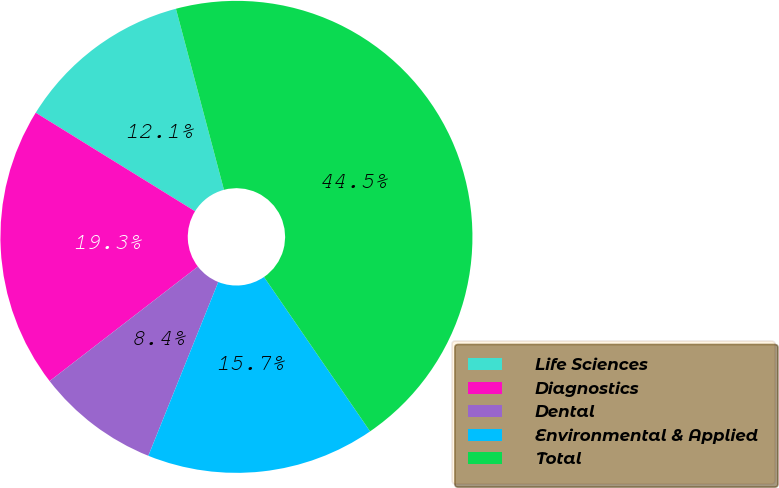<chart> <loc_0><loc_0><loc_500><loc_500><pie_chart><fcel>Life Sciences<fcel>Diagnostics<fcel>Dental<fcel>Environmental & Applied<fcel>Total<nl><fcel>12.06%<fcel>19.28%<fcel>8.45%<fcel>15.67%<fcel>44.55%<nl></chart> 